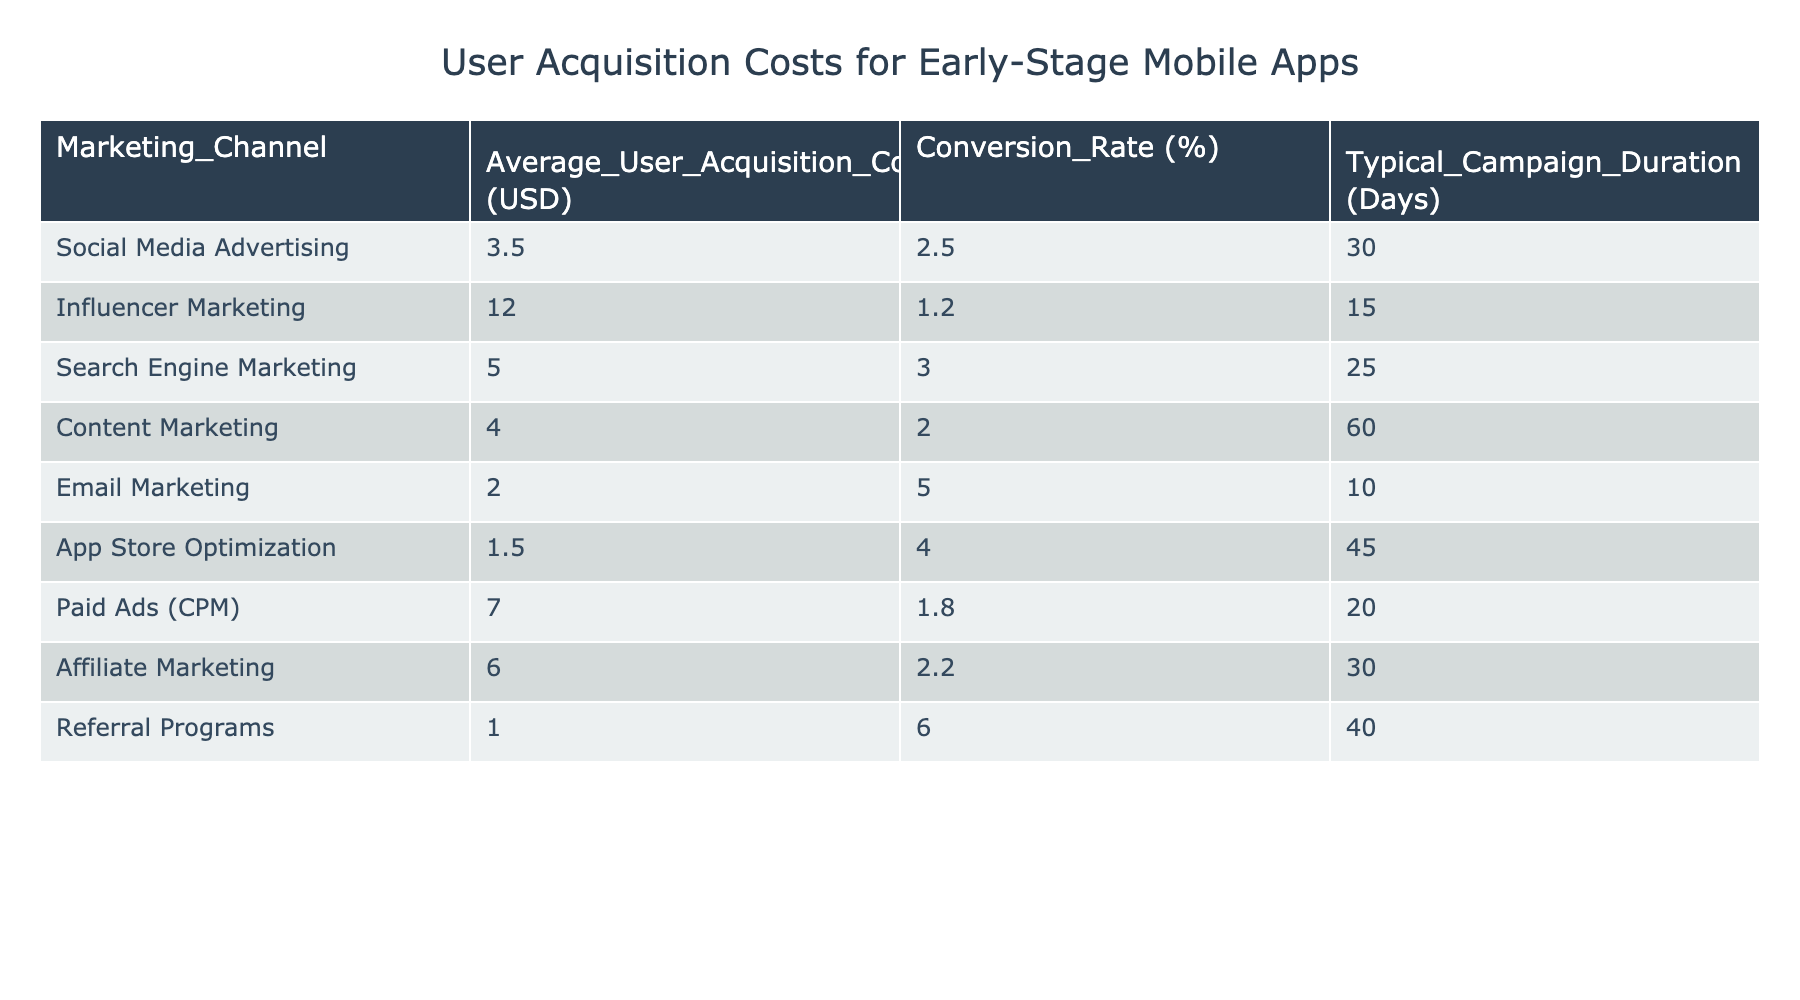What is the Average User Acquisition Cost for Referral Programs? The table lists the Average User Acquisition Cost for each marketing channel, and for Referral Programs, that value is explicitly listed as 1.00 USD.
Answer: 1.00 USD Which marketing channel has the highest Average User Acquisition Cost? By examining the Average User Acquisition Cost column, the highest value is for Influencer Marketing at 12.00 USD.
Answer: Influencer Marketing What is the total Average User Acquisition Cost for all marketing channels combined? To find the total, we sum up the Average User Acquisition Costs: 3.50 + 12.00 + 5.00 + 4.00 + 2.00 + 1.50 + 7.00 + 6.00 + 1.00 = 42.00 USD.
Answer: 42.00 USD Is the Conversion Rate for Email Marketing higher than that for Social Media Advertising? The table shows that Email Marketing has a Conversion Rate of 5.0%, while Social Media Advertising has a Conversion Rate of 2.5%. Since 5.0% is greater than 2.5%, the statement is true.
Answer: Yes Which two marketing channels have a typical campaign duration that exceeds 30 days? By reviewing the Typical Campaign Duration column, Content Marketing (60 days) and App Store Optimization (45 days) both exceed 30 days.
Answer: Content Marketing and App Store Optimization What is the average Conversion Rate across all marketing channels? To calculate the average, we sum the Conversion Rates: 2.5 + 1.2 + 3.0 + 2.0 + 5.0 + 4.0 + 1.8 + 2.2 + 6.0 = 28.7% and then divide by the number of channels (9): 28.7/9 ≈ 3.19%.
Answer: 3.19% If a venture spends 100 USD on Social Media Advertising, how many users do they expect to acquire based on the provided metrics? The Average User Acquisition Cost for Social Media Advertising is 3.50 USD. To find the expected users, we divide 100 USD by 3.50 USD to get approximately 28.57 users. Since partial users aren't counted, they can expect to acquire 28 users.
Answer: 28 users Does App Store Optimization have the lowest Average User Acquisition Cost? Comparing the Average User Acquisition Costs in the table, App Store Optimization at 1.50 USD is less than all others, confirming it is the lowest.
Answer: Yes What is the difference in Average User Acquisition Cost between Search Engine Marketing and Content Marketing? The Average User Acquisition Cost for Search Engine Marketing is 5.00 USD and for Content Marketing, it is 4.00 USD. The difference is 5.00 - 4.00 = 1.00 USD.
Answer: 1.00 USD 